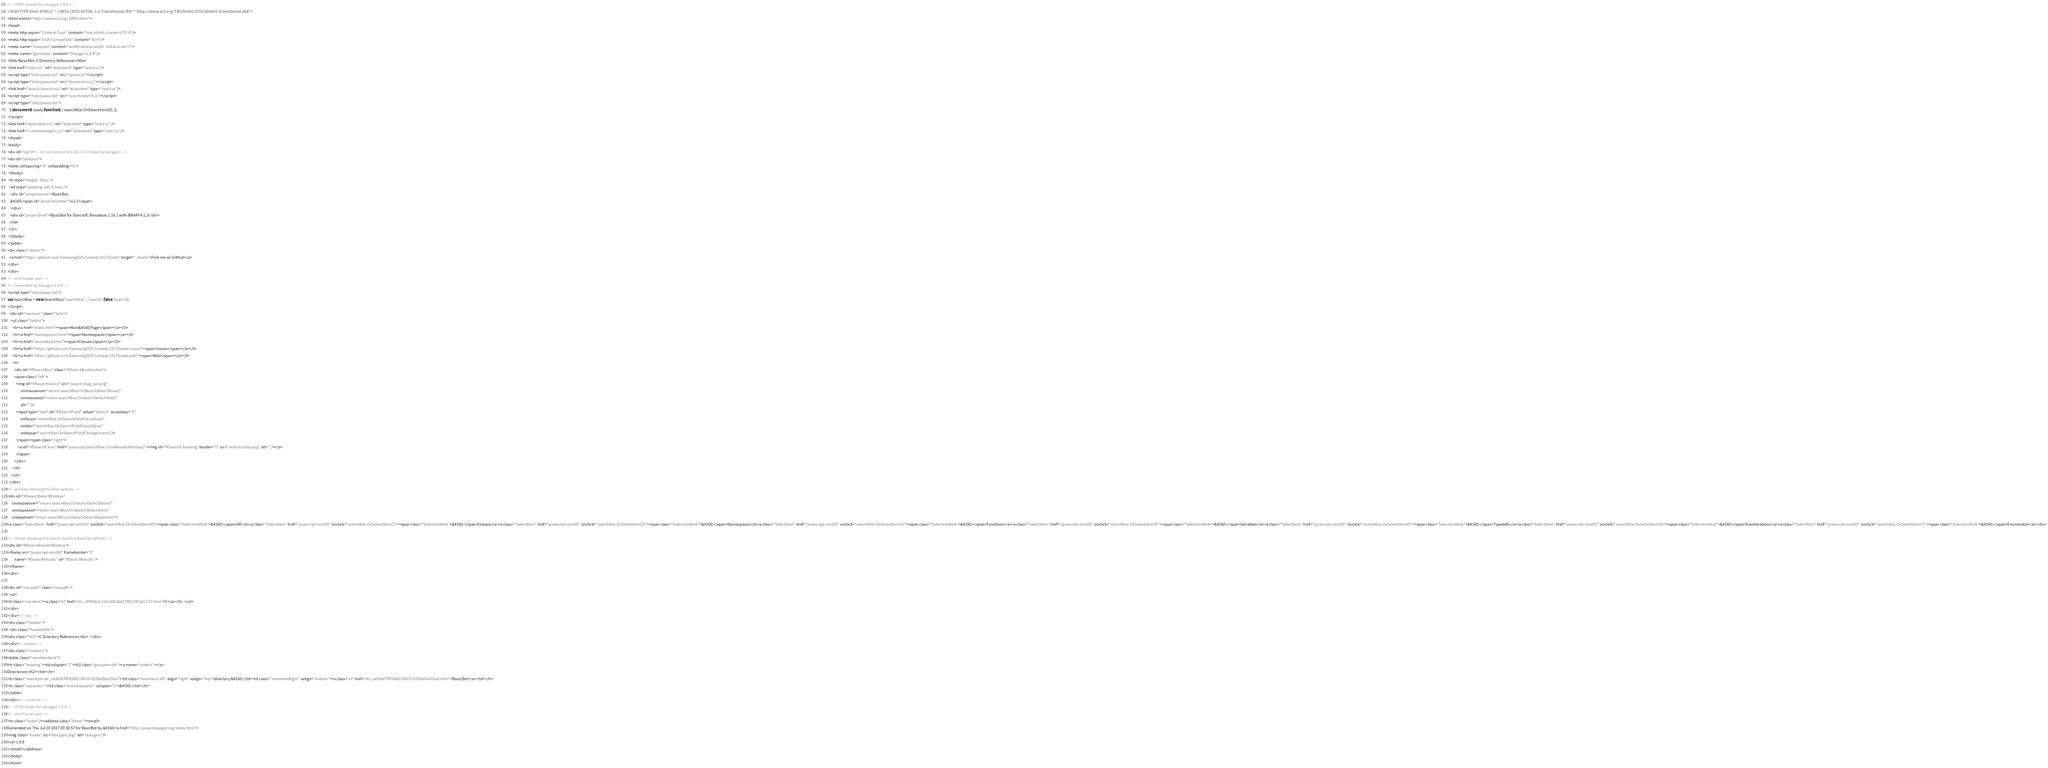Convert code to text. <code><loc_0><loc_0><loc_500><loc_500><_HTML_><!-- HTML header for doxygen 1.8.8-->
<!DOCTYPE html PUBLIC "-//W3C//DTD XHTML 1.0 Transitional//EN" "http://www.w3.org/TR/xhtml1/DTD/xhtml1-transitional.dtd">
<html xmlns="http://www.w3.org/1999/xhtml">
<head>
<meta http-equiv="Content-Type" content="text/xhtml;charset=UTF-8"/>
<meta http-equiv="X-UA-Compatible" content="IE=9"/>
<meta name="viewport" content="width=device-width, initial-scale=1">
<meta name="generator" content="Doxygen 1.8.8"/>
<title>BasicBot: C Directory Reference</title>
<link href="tabs.css" rel="stylesheet" type="text/css"/>
<script type="text/javascript" src="jquery.js"></script>
<script type="text/javascript" src="dynsections.js"></script>
<link href="search/search.css" rel="stylesheet" type="text/css"/>
<script type="text/javascript" src="search/search.js"></script>
<script type="text/javascript">
  $(document).ready(function() { searchBox.OnSelectItem(0); });
</script>
<link href="stylesheet.css" rel="stylesheet" type="text/css" />
<link href="customdoxygen.css" rel="stylesheet" type="text/css"/>
</head>
<body>
<div id="top"><!-- do not remove this div, it is closed by doxygen! -->
<div id="titlearea">
<table cellspacing="0" cellpadding="0">
 <tbody>
 <tr style="height: 56px;">
  <td style="padding-left: 0.5em;">
   <div id="projectname">BasicBot
   &#160;<span id="projectnumber">v1.1</span>
   </div>
   <div id="projectbrief">BasicBot for Starcraft: Broodwar 1.16.1 with BWAPI 4.1.2</div>
  </td>
 </tr>
 </tbody>
</table>
<div class="ribbon">
  <a href="https://github.com/SamsungSDS-Contest/2017Guide" target="_blank">Fork me on GitHub</a>
</div>
</div>
<!-- end header part -->
<!-- Generated by Doxygen 1.8.8 -->
<script type="text/javascript">
var searchBox = new SearchBox("searchBox", "search",false,'Search');
</script>
  <div id="navrow1" class="tabs">
    <ul class="tablist">
      <li><a href="index.html"><span>Main&#160;Page</span></a></li>
      <li><a href="namespaces.html"><span>Namespaces</span></a></li>
      <li><a href="annotated.html"><span>Classes</span></a></li>
      <li><a href="https://github.com/SamsungSDS-Contest/2017Guide/issues"><span>Issues</span></a></li>
      <li><a href="https://github.com/SamsungSDS-Contest/2017Guide/wiki"><span>Wiki</span></a></li>
      <li>
        <div id="MSearchBox" class="MSearchBoxInactive">
        <span class="left">
          <img id="MSearchSelect" src="search/mag_sel.png"
               onmouseover="return searchBox.OnSearchSelectShow()"
               onmouseout="return searchBox.OnSearchSelectHide()"
               alt=""/>
          <input type="text" id="MSearchField" value="Search" accesskey="S"
               onfocus="searchBox.OnSearchFieldFocus(true)" 
               onblur="searchBox.OnSearchFieldFocus(false)" 
               onkeyup="searchBox.OnSearchFieldChange(event)"/>
          </span><span class="right">
            <a id="MSearchClose" href="javascript:searchBox.CloseResultsWindow()"><img id="MSearchCloseImg" border="0" src="search/close.png" alt=""/></a>
          </span>
        </div>
      </li>
    </ul>
  </div>
<!-- window showing the filter options -->
<div id="MSearchSelectWindow"
     onmouseover="return searchBox.OnSearchSelectShow()"
     onmouseout="return searchBox.OnSearchSelectHide()"
     onkeydown="return searchBox.OnSearchSelectKey(event)">
<a class="SelectItem" href="javascript:void(0)" onclick="searchBox.OnSelectItem(0)"><span class="SelectionMark">&#160;</span>All</a><a class="SelectItem" href="javascript:void(0)" onclick="searchBox.OnSelectItem(1)"><span class="SelectionMark">&#160;</span>Classes</a><a class="SelectItem" href="javascript:void(0)" onclick="searchBox.OnSelectItem(2)"><span class="SelectionMark">&#160;</span>Namespaces</a><a class="SelectItem" href="javascript:void(0)" onclick="searchBox.OnSelectItem(3)"><span class="SelectionMark">&#160;</span>Functions</a><a class="SelectItem" href="javascript:void(0)" onclick="searchBox.OnSelectItem(4)"><span class="SelectionMark">&#160;</span>Variables</a><a class="SelectItem" href="javascript:void(0)" onclick="searchBox.OnSelectItem(5)"><span class="SelectionMark">&#160;</span>Typedefs</a><a class="SelectItem" href="javascript:void(0)" onclick="searchBox.OnSelectItem(6)"><span class="SelectionMark">&#160;</span>Enumerations</a><a class="SelectItem" href="javascript:void(0)" onclick="searchBox.OnSelectItem(7)"><span class="SelectionMark">&#160;</span>Enumerator</a></div>

<!-- iframe showing the search results (closed by default) -->
<div id="MSearchResultsWindow">
<iframe src="javascript:void(0)" frameborder="0" 
        name="MSearchResults" id="MSearchResults">
</iframe>
</div>

<div id="nav-path" class="navpath">
  <ul>
<li class="navelem"><a class="el" href="dir_af99bb3c152a306abd27951285ad1127.html">C</a></li>  </ul>
</div>
</div><!-- top -->
<div class="header">
  <div class="headertitle">
<div class="title">C Directory Reference</div>  </div>
</div><!--header-->
<div class="contents">
<table class="memberdecls">
<tr class="heading"><td colspan="2"><h2 class="groupheader"><a name="subdirs"></a>
Directories</h2></td></tr>
<tr class="memitem:dir_ee9daf7f850d82149c07d29bd6be59ad"><td class="memItemLeft" align="right" valign="top">directory &#160;</td><td class="memItemRight" valign="bottom"><a class="el" href="dir_ee9daf7f850d82149c07d29bd6be59ad.html">BasicBot</a></td></tr>
<tr class="separator:"><td class="memSeparator" colspan="2">&#160;</td></tr>
</table>
</div><!-- contents -->
<!-- HTML footer for doxygen 1.8.8-->
<!-- start footer part -->
<hr class="footer"/><address class="footer"><small>
Generated on Thu Jul 20 2017 00:30:57 for BasicBot by &#160;<a href="http://www.doxygen.org/index.html">
<img class="footer" src="doxygen.png" alt="doxygen"/>
</a> 1.8.8
</small></address>
</body>
</html>
</code> 